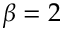Convert formula to latex. <formula><loc_0><loc_0><loc_500><loc_500>\beta = 2</formula> 